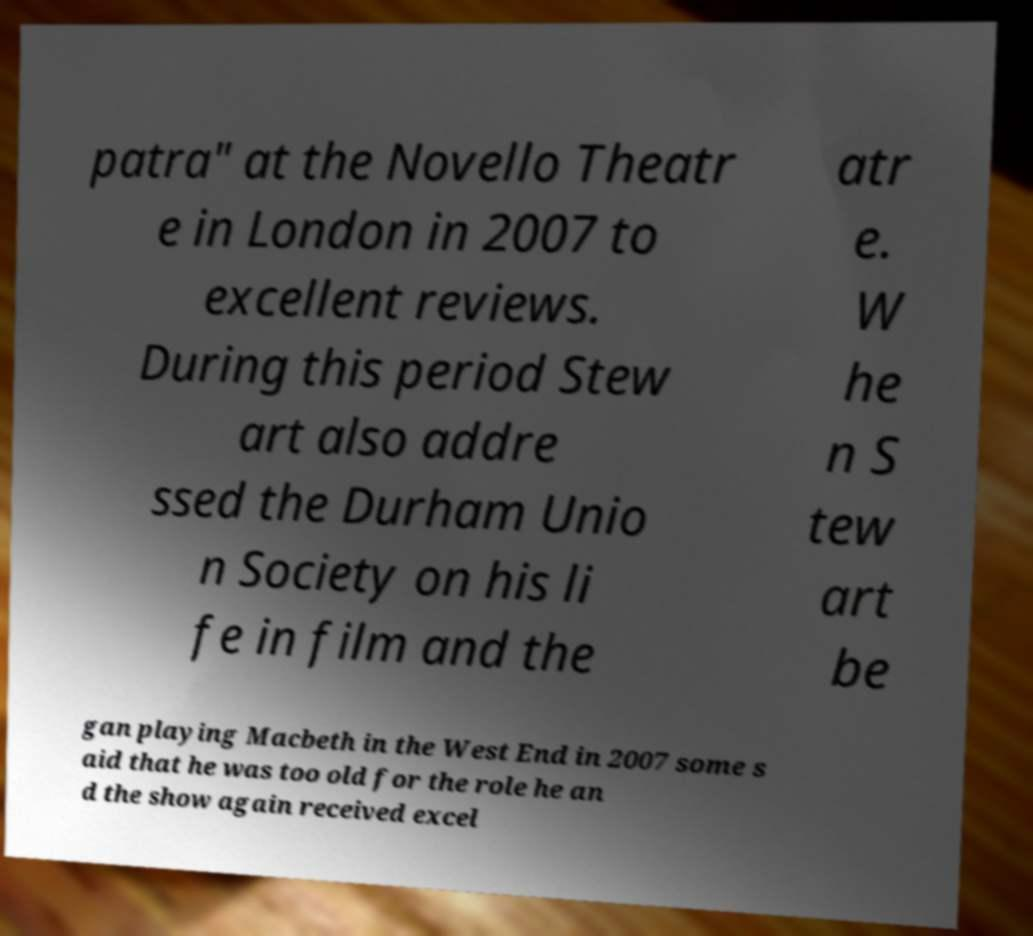There's text embedded in this image that I need extracted. Can you transcribe it verbatim? patra" at the Novello Theatr e in London in 2007 to excellent reviews. During this period Stew art also addre ssed the Durham Unio n Society on his li fe in film and the atr e. W he n S tew art be gan playing Macbeth in the West End in 2007 some s aid that he was too old for the role he an d the show again received excel 